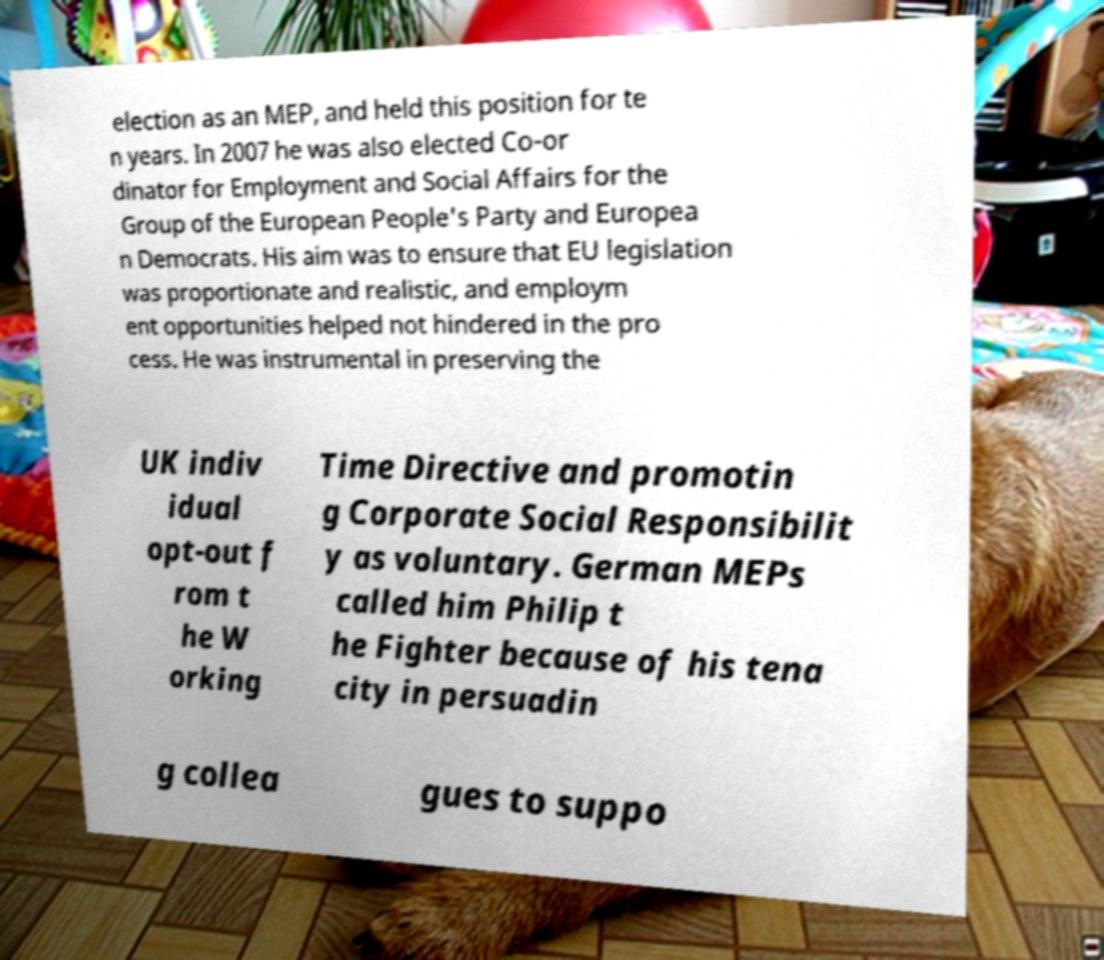I need the written content from this picture converted into text. Can you do that? election as an MEP, and held this position for te n years. In 2007 he was also elected Co-or dinator for Employment and Social Affairs for the Group of the European People's Party and Europea n Democrats. His aim was to ensure that EU legislation was proportionate and realistic, and employm ent opportunities helped not hindered in the pro cess. He was instrumental in preserving the UK indiv idual opt-out f rom t he W orking Time Directive and promotin g Corporate Social Responsibilit y as voluntary. German MEPs called him Philip t he Fighter because of his tena city in persuadin g collea gues to suppo 